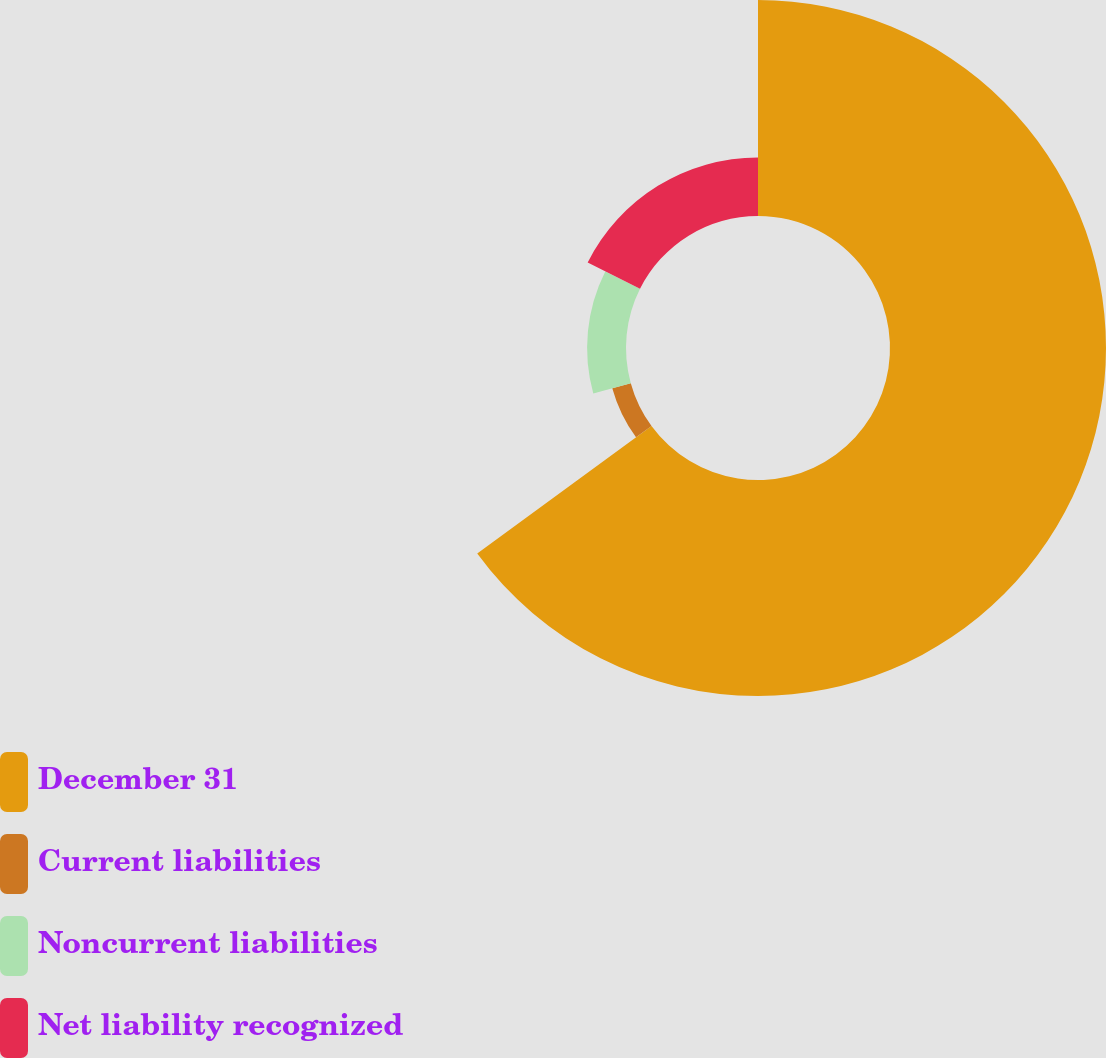Convert chart to OTSL. <chart><loc_0><loc_0><loc_500><loc_500><pie_chart><fcel>December 31<fcel>Current liabilities<fcel>Noncurrent liabilities<fcel>Net liability recognized<nl><fcel>64.94%<fcel>5.77%<fcel>11.69%<fcel>17.6%<nl></chart> 